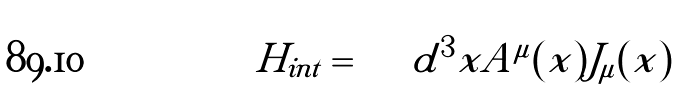<formula> <loc_0><loc_0><loc_500><loc_500>H _ { i n t } = \int d ^ { 3 } x A ^ { \mu } ( x ) J _ { \mu } ( x )</formula> 